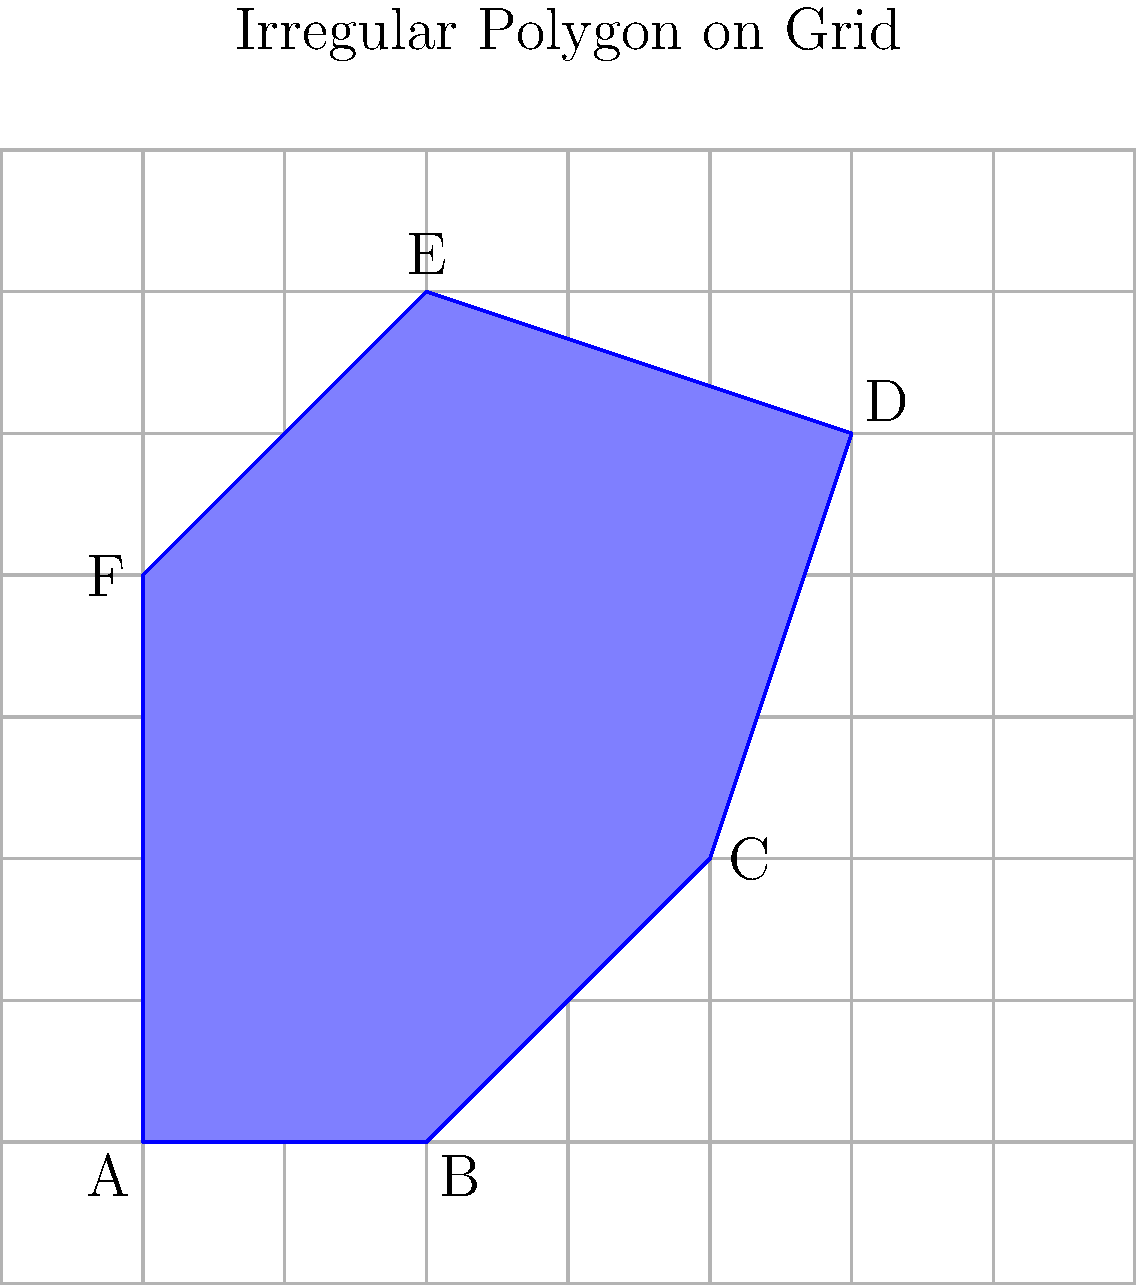Using the grid system shown in the image, estimate the area of the irregular blue polygon ABCDEF. Each square in the grid represents 1 square unit. Round your answer to the nearest whole number. To estimate the area of the irregular polygon using the grid system, we'll follow these steps:

1. Count the number of whole squares inside the polygon:
   There are approximately 13 whole squares within the polygon.

2. Count the number of partial squares:
   There are about 12 partial squares around the edges of the polygon.

3. Estimate the area of partial squares:
   We can approximate that half of each partial square is inside the polygon.
   So, the area of partial squares is about: $12 \times 0.5 = 6$ square units

4. Sum up the total area:
   Total area = Whole squares + Partial squares
   $$ \text{Total area} = 13 + 6 = 19 \text{ square units} $$

5. Round to the nearest whole number:
   The estimated area is 19 square units, which is already a whole number.

This method of estimating irregular areas using a grid system is similar to the concept of pixel-based measurements in front-end development, where we often work with grids and pixel-perfect designs.
Answer: 19 square units 